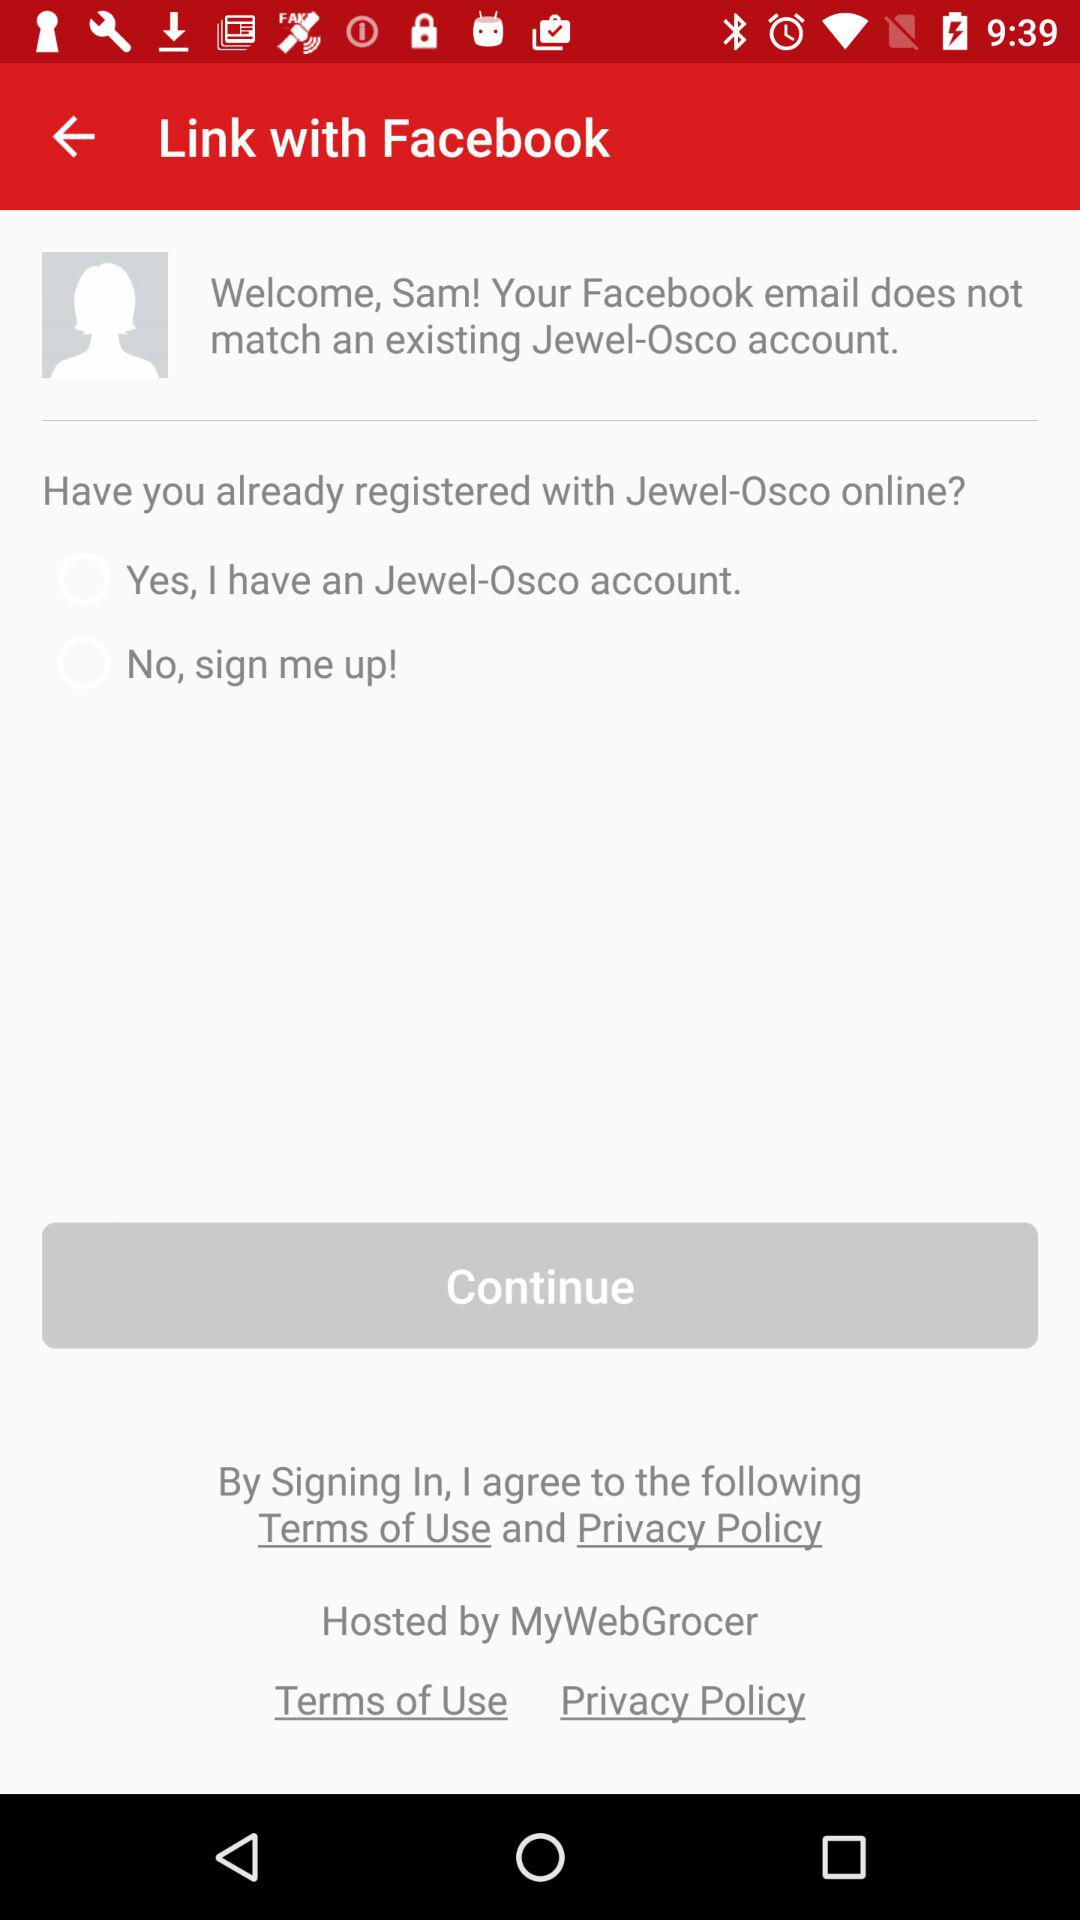What is the status of "No, Sign me up!"? The status is "off". 